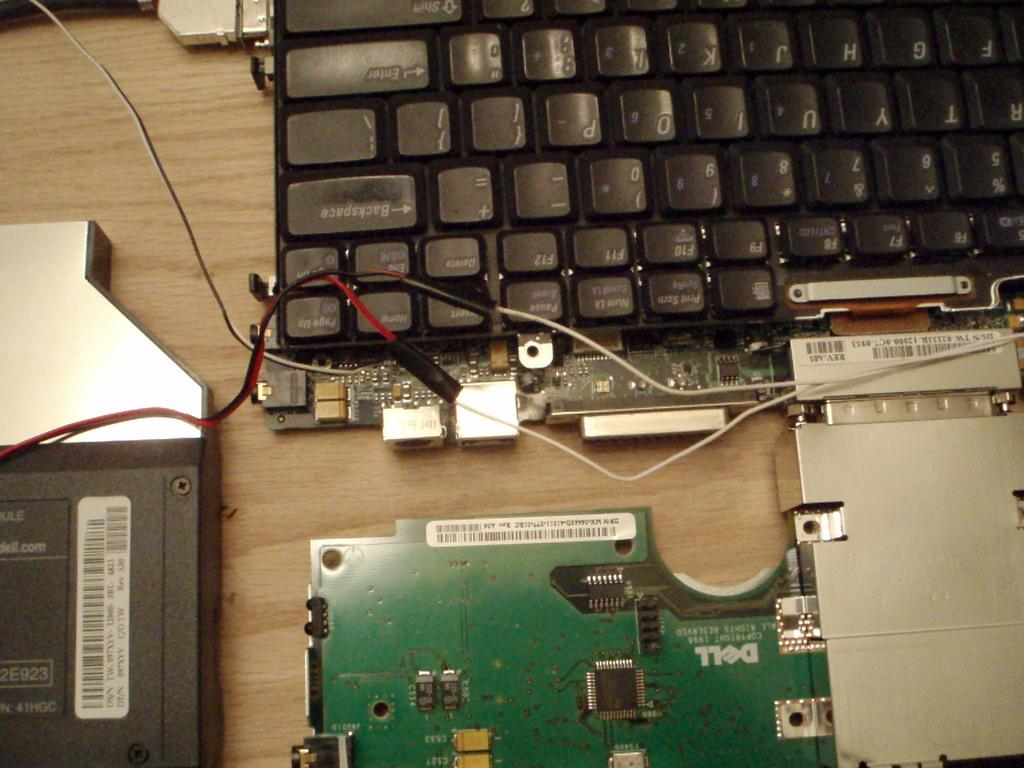<image>
Render a clear and concise summary of the photo. A Dell computer is taken apart on a wood desk. 